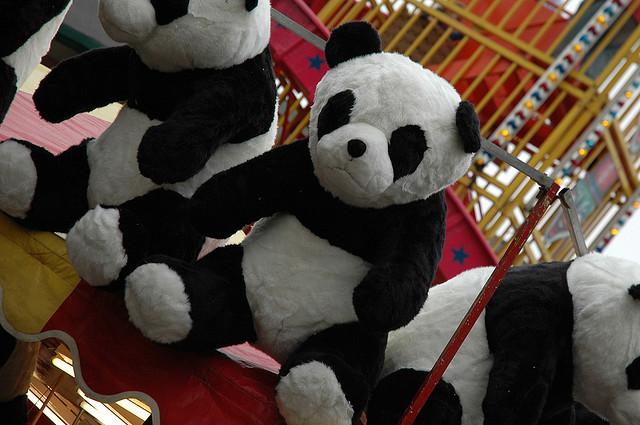Could these be carnival prizes?
Keep it brief. Yes. What type of bear is shown?
Short answer required. Panda. Are the bears all the same color?
Write a very short answer. Yes. 